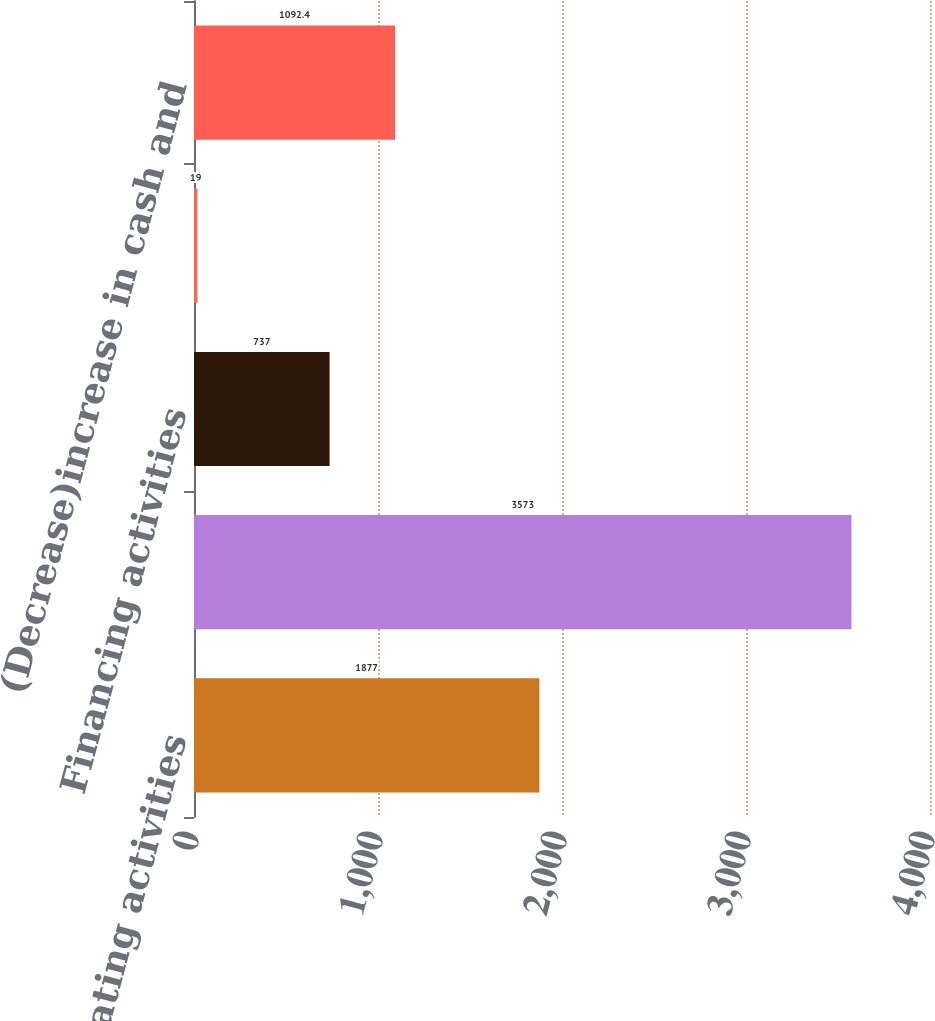Convert chart. <chart><loc_0><loc_0><loc_500><loc_500><bar_chart><fcel>Operating activities<fcel>Investing activities<fcel>Financing activities<fcel>Effect of exchange rate<fcel>(Decrease)increase in cash and<nl><fcel>1877<fcel>3573<fcel>737<fcel>19<fcel>1092.4<nl></chart> 